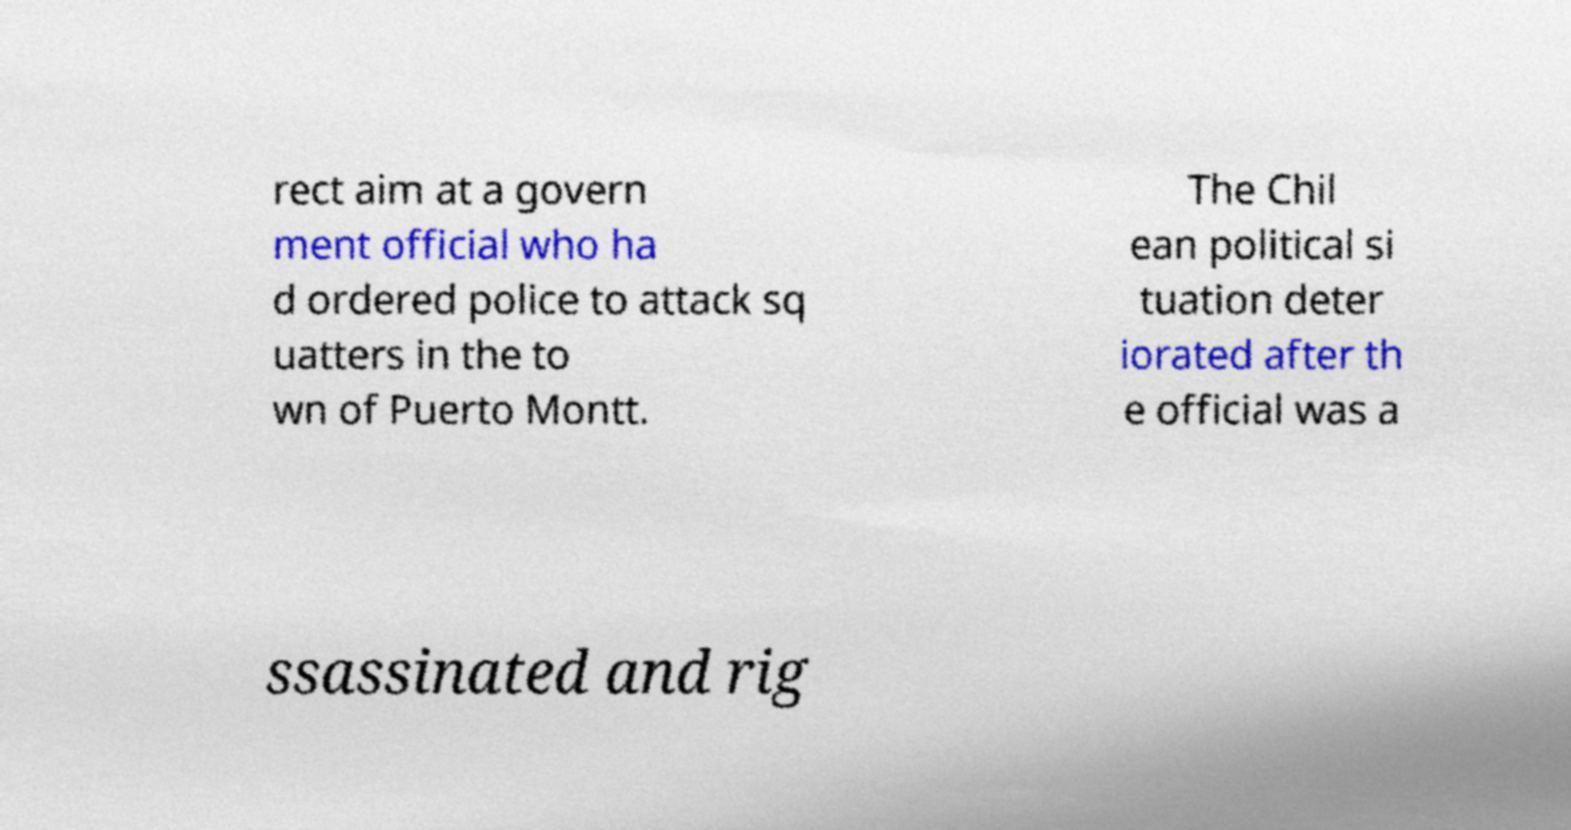Can you accurately transcribe the text from the provided image for me? rect aim at a govern ment official who ha d ordered police to attack sq uatters in the to wn of Puerto Montt. The Chil ean political si tuation deter iorated after th e official was a ssassinated and rig 